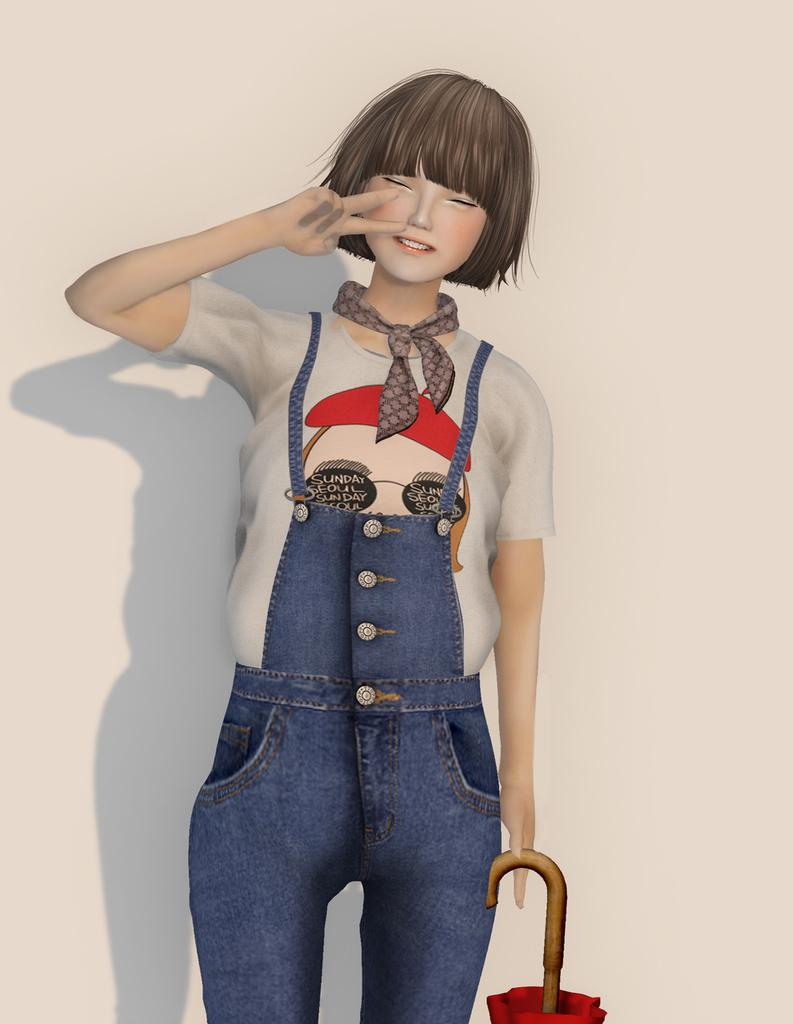What type of image is being described? The image is animated. Can you describe the main character in the image? There is a girl in the image. What is the girl doing in the image? The girl is standing. What object is the girl holding in the image? The girl is holding an umbrella. What type of clothing is the girl wearing in the image? The girl is wearing a dungaree. What color is the background of the image? The background of the image is white. What type of finger food can be seen in the alley during the event in the image? There is no alley or event present in the image, and therefore no finger food can be observed. 